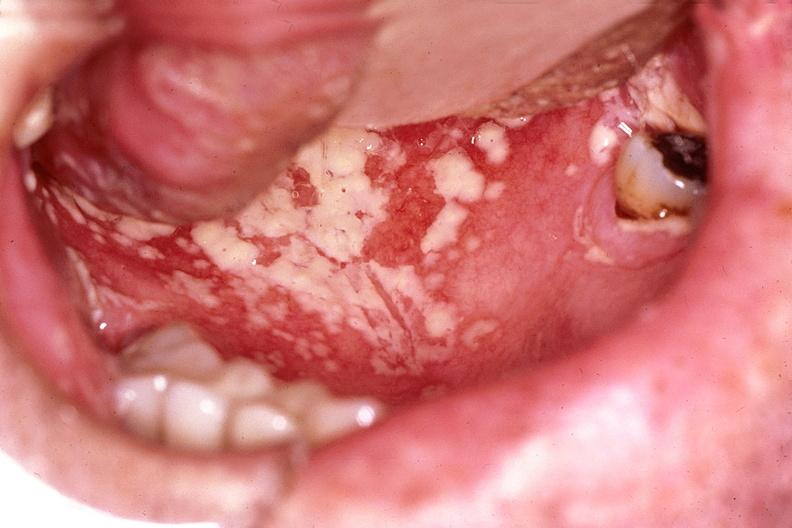s nodule present?
Answer the question using a single word or phrase. No 